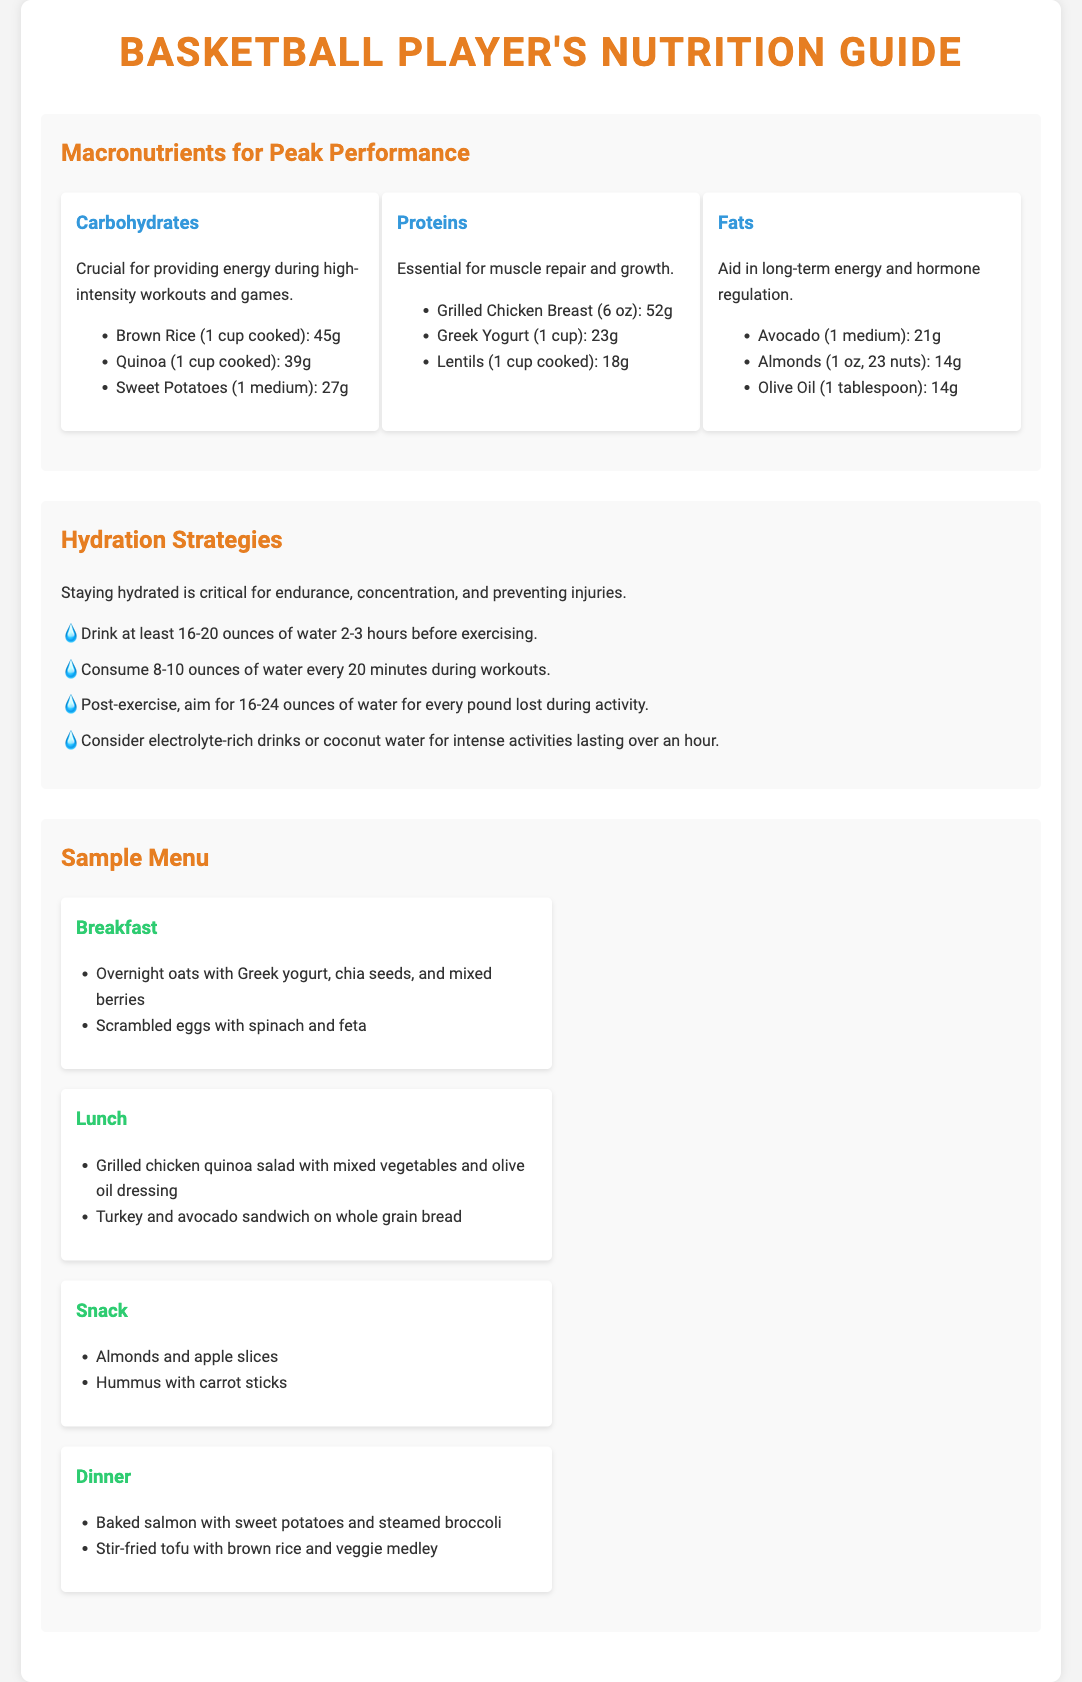What are the three macronutrients highlighted? The document explicitly lists carbohydrates, proteins, and fats as the three macronutrients for peak performance.
Answer: Carbohydrates, proteins, fats What is the carbohydrate content of quinoa per cup cooked? The document states that quinoa contains 39 grams of carbohydrates per cup when cooked.
Answer: 39g How much water should be consumed post-exercise per pound lost? According to the hydration strategies, it is recommended to consume 16-24 ounces of water for every pound lost during activity.
Answer: 16-24 ounces What is a rich source of protein mentioned in the snacks section? The snacks section lists almonds as a protein-rich snack option among others.
Answer: Almonds How much should you drink 2-3 hours before exercising? The document specifies that you should drink at least 16-20 ounces of water 2-3 hours before exercising.
Answer: 16-20 ounces What meal contains baked salmon? The dinner section indicates that the meal featuring baked salmon is included.
Answer: Dinner Which item has the highest fat content listed in the fats section? The fats section lists avocado, which has a higher fat content compared to the other items.
Answer: Avocado What is the primary purpose of carbohydrates for athletes? The document describes carbohydrates as crucial for providing energy during workouts and games.
Answer: Providing energy What is the recommended hydration during workouts? The document advises consuming 8-10 ounces of water every 20 minutes during workouts.
Answer: 8-10 ounces 